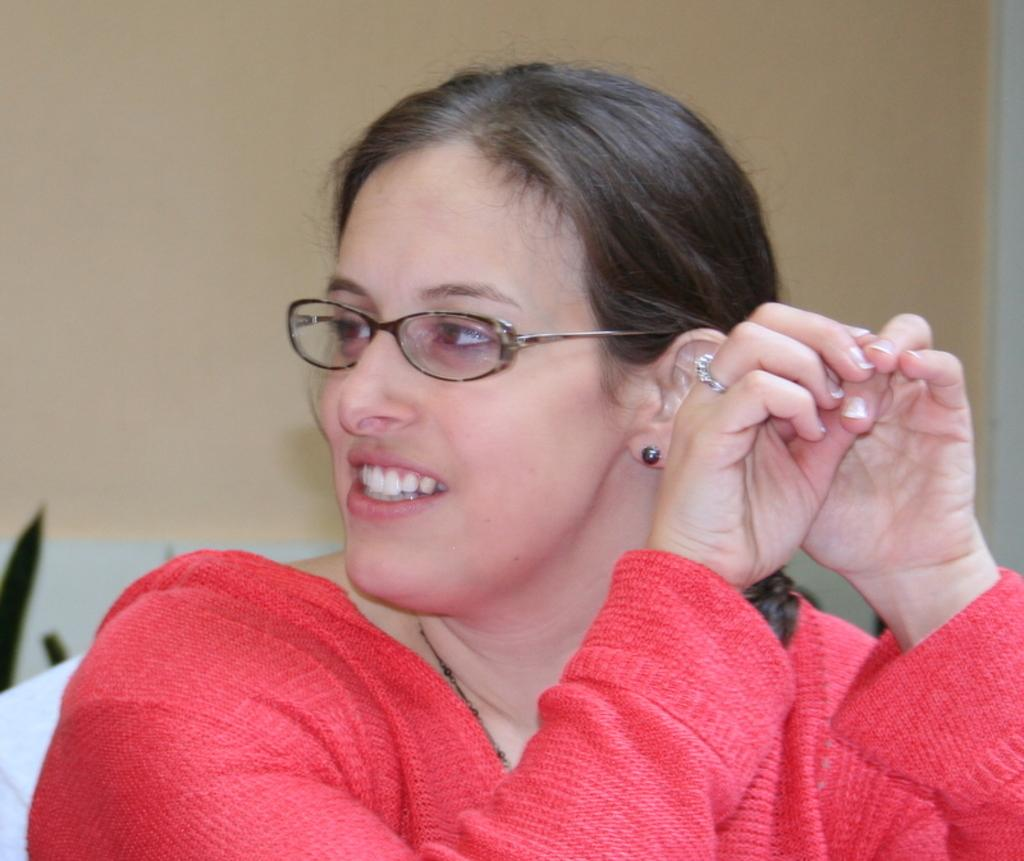Who is present in the image? There is a woman in the image. What is the woman wearing? The woman is wearing a red dress. What expression does the woman have? The woman is smiling. What can be seen in the background of the image? There is a wall in the background of the image. Can you see any wounds on the woman's face in the image? There is no indication of any wounds on the woman's face in the image. 